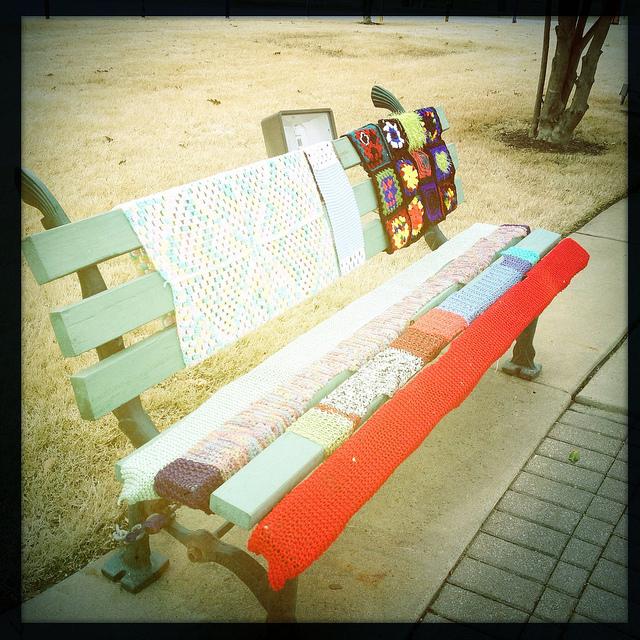Would the bench covering be waterproof?
Be succinct. No. Is the ground clean or dirty?
Concise answer only. Clean. Is the bench wood?
Give a very brief answer. Yes. What time of day is it?
Be succinct. Daytime. Is the book on the back of the bench or the seat?
Write a very short answer. No. Is there a fan in this photo?
Short answer required. No. How many people can sit on this bench?
Give a very brief answer. 3. What color is the grass?
Be succinct. Brown. 